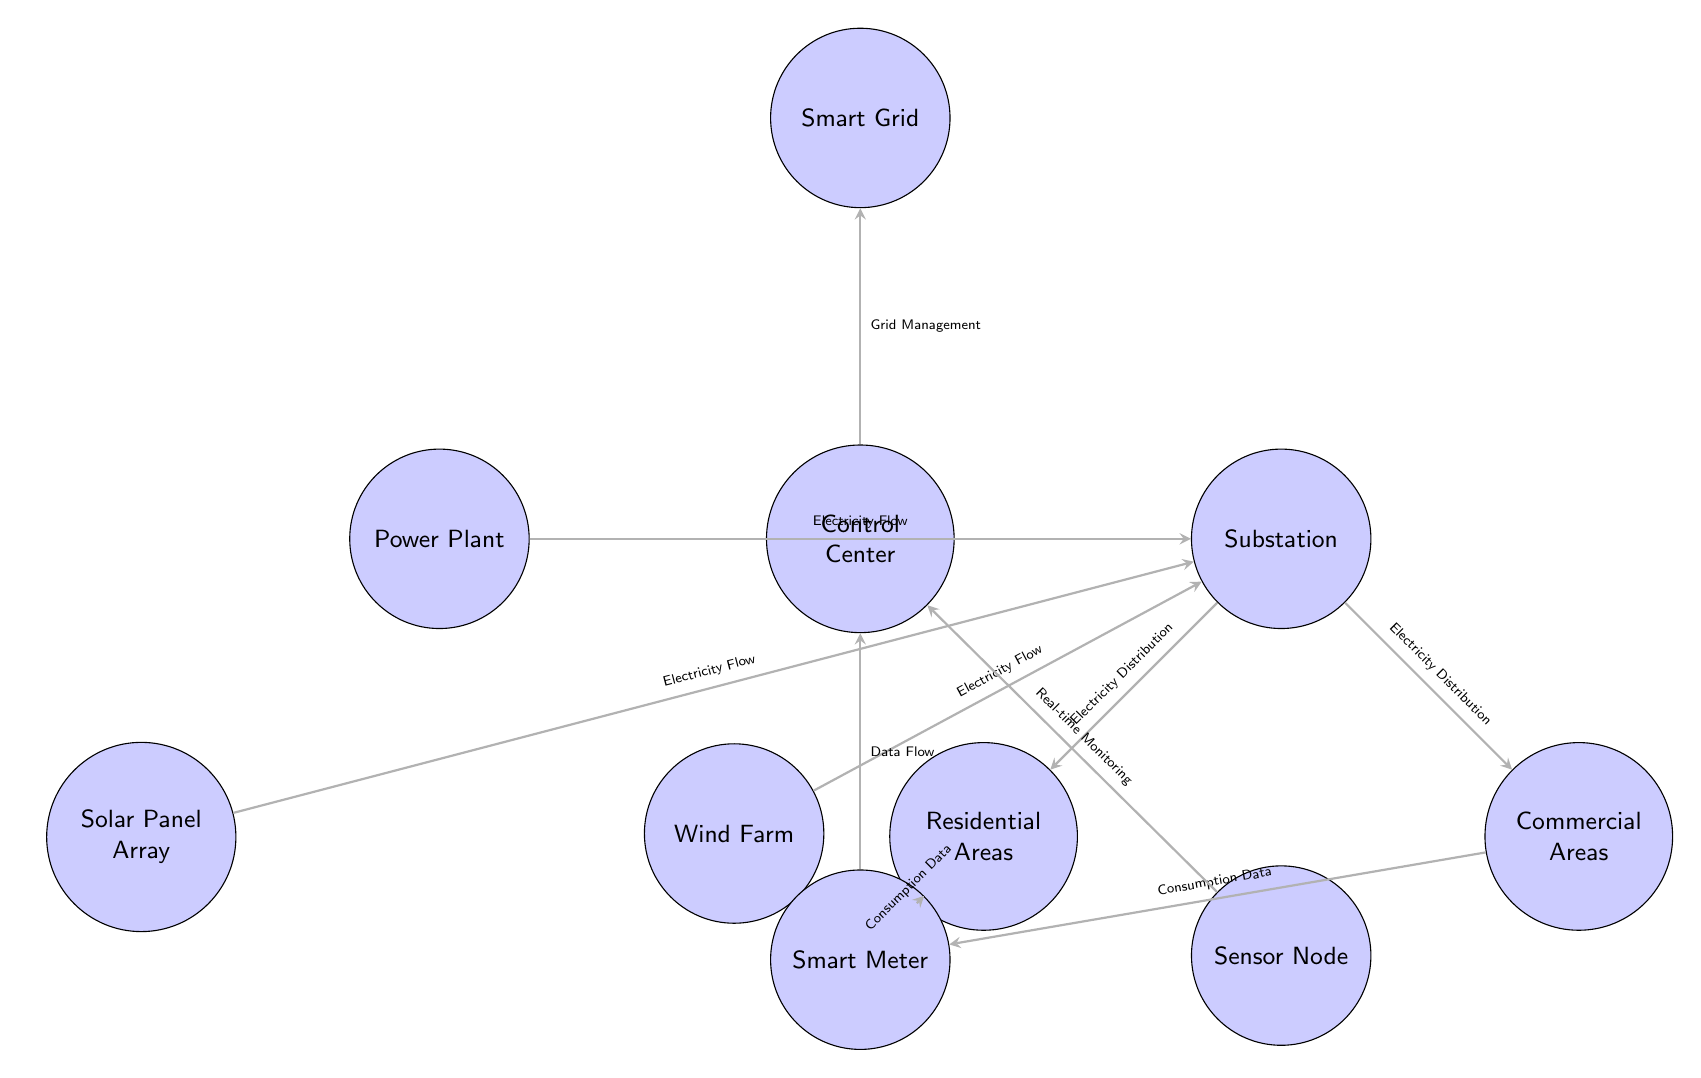What is the first node in the diagram? The first node in the diagram is the "Smart Grid" which is positioned at the top. This node represents the overall infrastructure that is being managed in the energy distribution system.
Answer: Smart Grid How many energy sources feed into the substation? The substation receives electricity from three energy sources: the Power Plant, Solar Panel Array, and Wind Farm. These are the nodes that directly connect to the substation in the diagram.
Answer: Three What type of data flows from the residential areas to the smart meter? The type of data that flows from the residential areas to the smart meter is "Consumption Data." This is indicated by the directed arrow connecting these two nodes in the diagram.
Answer: Consumption Data Which node is responsible for real-time monitoring? The node responsible for real-time monitoring is the "Sensor Node." It sends monitoring data to the Control Center, as shown by the directed arrow leading from the Sensor Node to the Control Center.
Answer: Sensor Node What connection does the Control Center have with the Smart Grid? The Control Center is connected to the Smart Grid by means of "Grid Management." This is indicated by a directed arrow from the Control Center to the Smart Grid in the diagram.
Answer: Grid Management Which areas receive electricity from the substation? The areas that receive electricity from the substation are "Residential Areas" and "Commercial Areas." Both are positioned below the substation and have outgoing connections.
Answer: Residential Areas and Commercial Areas How is the electricity distributed from the substation? Electricity is distributed from the substation to both residential and commercial areas, indicated by arrows pointing from the substation to these two nodes.
Answer: Electricity Distribution Where does the consumption data from commercial areas go? The consumption data from commercial areas flows to the smart meter. This is represented by the arrow leading from the commercial node to the smart meter in the diagram.
Answer: Smart Meter What is the role of the Control Center in this diagram? The role of the Control Center is to manage the grid, as indicated by the flow from the Control Center to the Smart Grid, labeled as "Grid Management." This shows its function in overseeing the overall distribution system.
Answer: Manage the Grid 